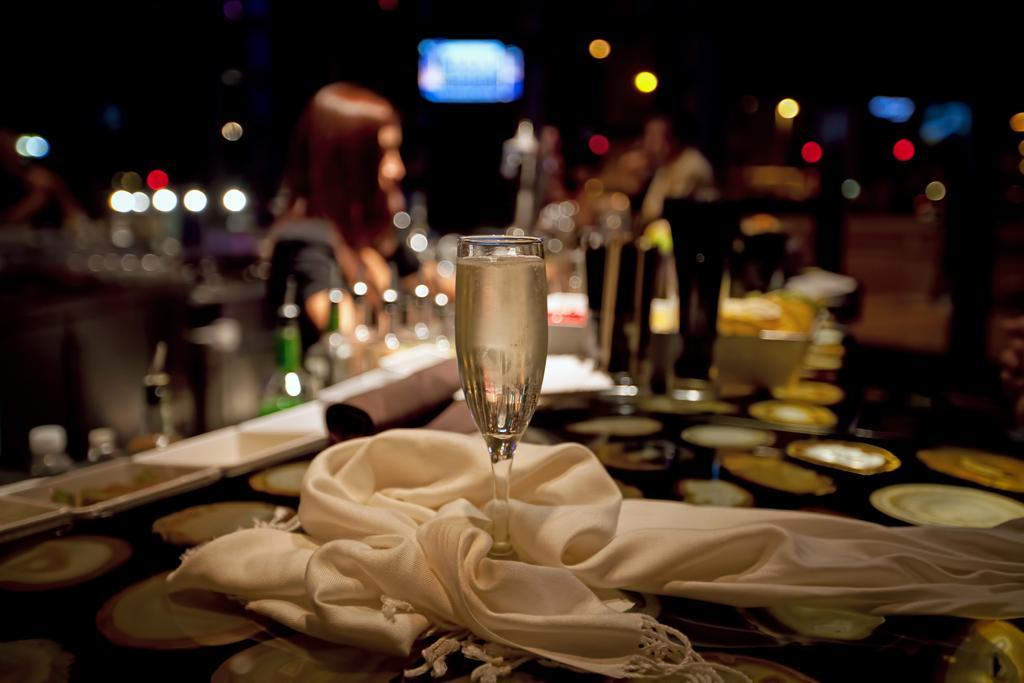How would you summarize this image in a sentence or two? In the image there is a glass filled with some drink kept on a table and around that glass there is a white cloth and the background of the glass is blurry. 